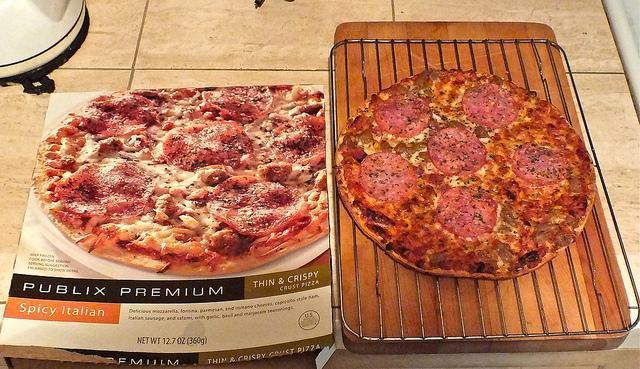How many pizzas are in the picture?
Give a very brief answer. 2. 